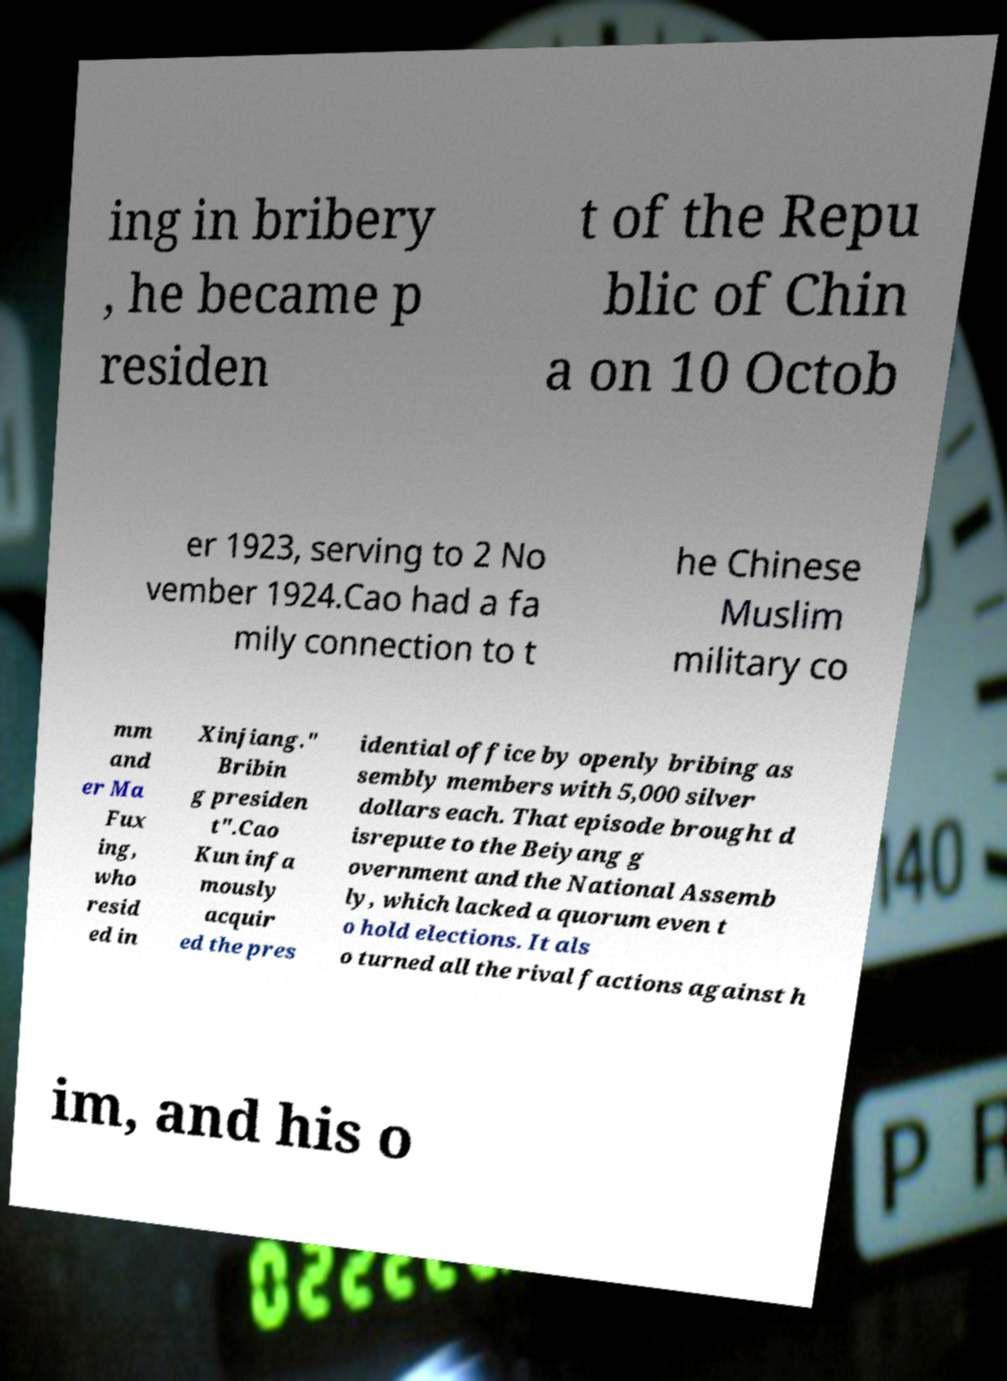There's text embedded in this image that I need extracted. Can you transcribe it verbatim? ing in bribery , he became p residen t of the Repu blic of Chin a on 10 Octob er 1923, serving to 2 No vember 1924.Cao had a fa mily connection to t he Chinese Muslim military co mm and er Ma Fux ing, who resid ed in Xinjiang." Bribin g presiden t".Cao Kun infa mously acquir ed the pres idential office by openly bribing as sembly members with 5,000 silver dollars each. That episode brought d isrepute to the Beiyang g overnment and the National Assemb ly, which lacked a quorum even t o hold elections. It als o turned all the rival factions against h im, and his o 